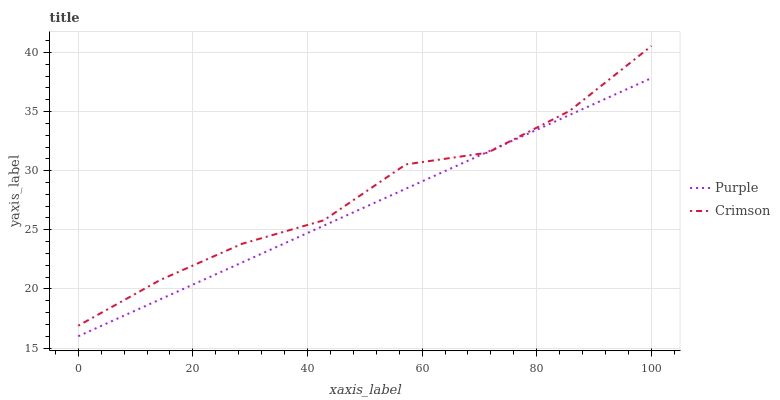Does Purple have the minimum area under the curve?
Answer yes or no. Yes. Does Crimson have the maximum area under the curve?
Answer yes or no. Yes. Does Crimson have the minimum area under the curve?
Answer yes or no. No. Is Purple the smoothest?
Answer yes or no. Yes. Is Crimson the roughest?
Answer yes or no. Yes. Is Crimson the smoothest?
Answer yes or no. No. Does Crimson have the lowest value?
Answer yes or no. No. Does Crimson have the highest value?
Answer yes or no. Yes. Does Crimson intersect Purple?
Answer yes or no. Yes. Is Crimson less than Purple?
Answer yes or no. No. Is Crimson greater than Purple?
Answer yes or no. No. 